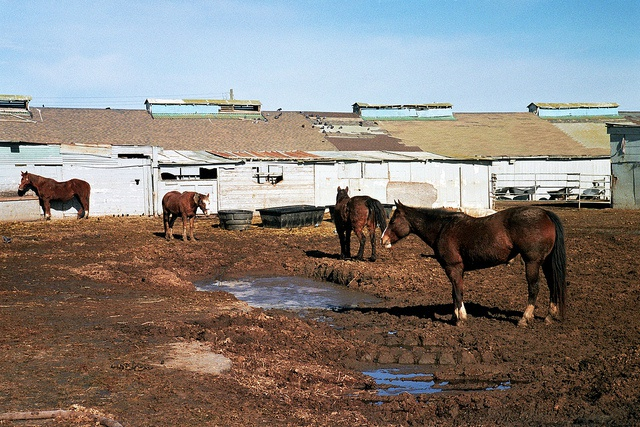Describe the objects in this image and their specific colors. I can see horse in lightblue, black, maroon, and brown tones, horse in lightblue, black, maroon, and brown tones, horse in lightblue, black, maroon, brown, and white tones, and horse in lightblue, maroon, black, and brown tones in this image. 